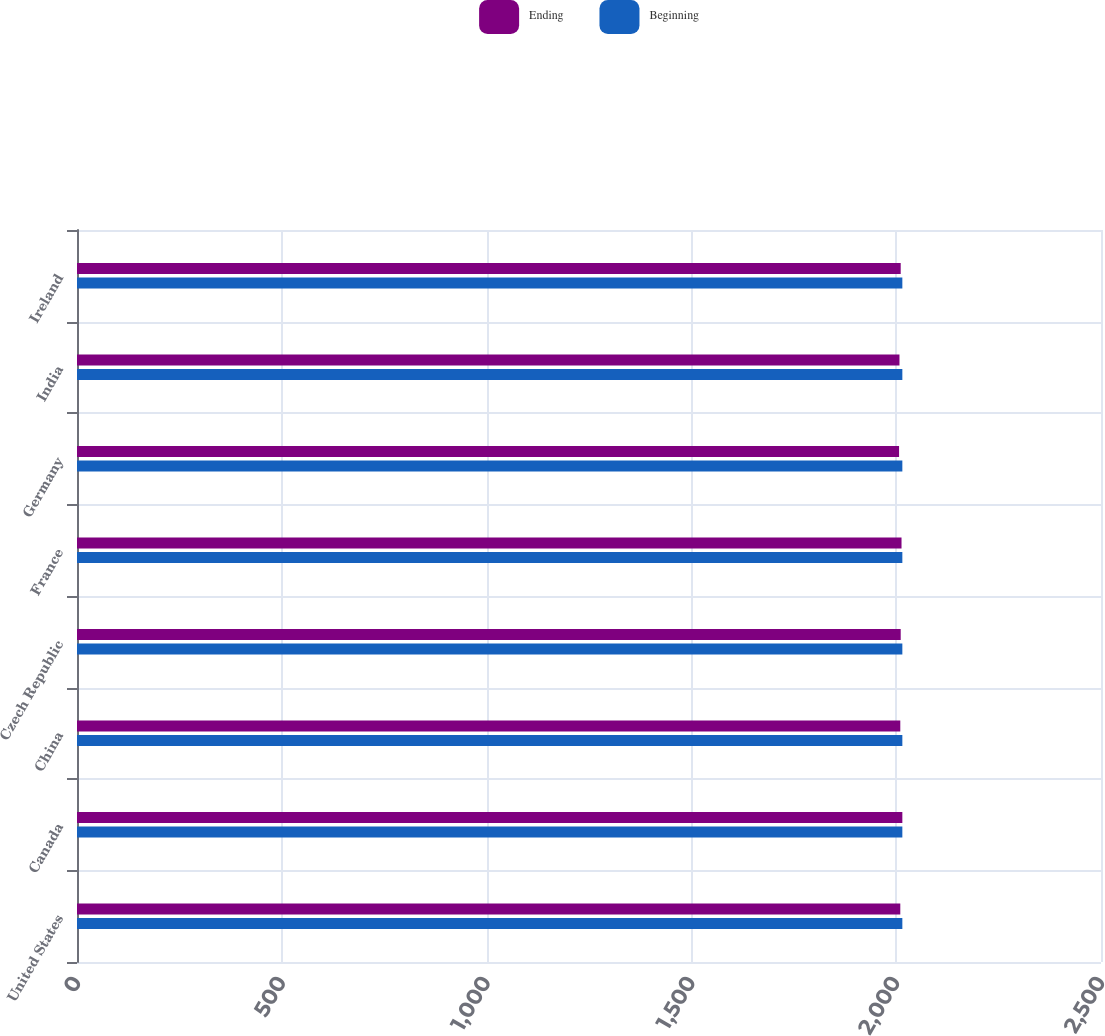<chart> <loc_0><loc_0><loc_500><loc_500><stacked_bar_chart><ecel><fcel>United States<fcel>Canada<fcel>China<fcel>Czech Republic<fcel>France<fcel>Germany<fcel>India<fcel>Ireland<nl><fcel>Ending<fcel>2010<fcel>2015<fcel>2010<fcel>2011<fcel>2013<fcel>2007<fcel>2008<fcel>2011<nl><fcel>Beginning<fcel>2015<fcel>2015<fcel>2015<fcel>2015<fcel>2015<fcel>2015<fcel>2015<fcel>2015<nl></chart> 